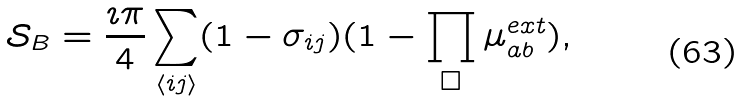<formula> <loc_0><loc_0><loc_500><loc_500>\mathcal { S } _ { B } = \frac { \imath \pi } { 4 } \sum _ { \langle i j \rangle } ( 1 - \sigma _ { i j } ) ( 1 - \prod _ { \Box } \mu ^ { e x t } _ { a b } ) ,</formula> 